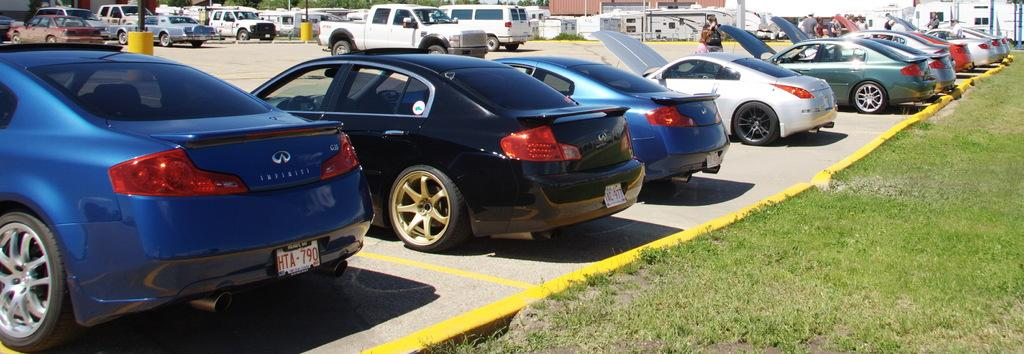What can be seen in the image related to vehicles? There are cars parked in the image. Where are the cars parked? The cars are parked in an area. What type of vegetation is present on the right side of the image? There is land covered with grass on the right side of the image. Can you describe the presence of a person in the image? There is a person standing behind one of the cars. What type of comb is the person using to groom the sweater in the image? There is no person grooming a sweater with a comb in the image. 